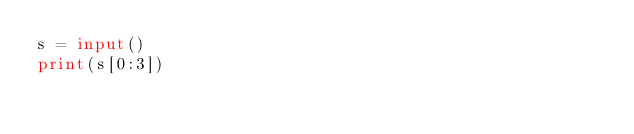Convert code to text. <code><loc_0><loc_0><loc_500><loc_500><_Python_>s = input()
print(s[0:3])</code> 